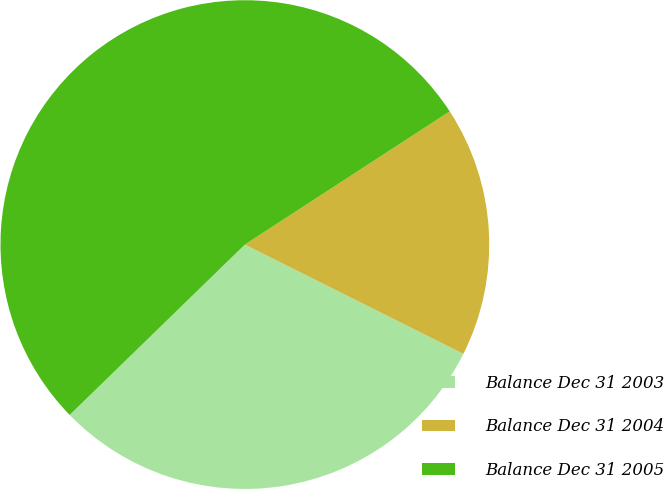Convert chart. <chart><loc_0><loc_0><loc_500><loc_500><pie_chart><fcel>Balance Dec 31 2003<fcel>Balance Dec 31 2004<fcel>Balance Dec 31 2005<nl><fcel>30.34%<fcel>16.55%<fcel>53.1%<nl></chart> 